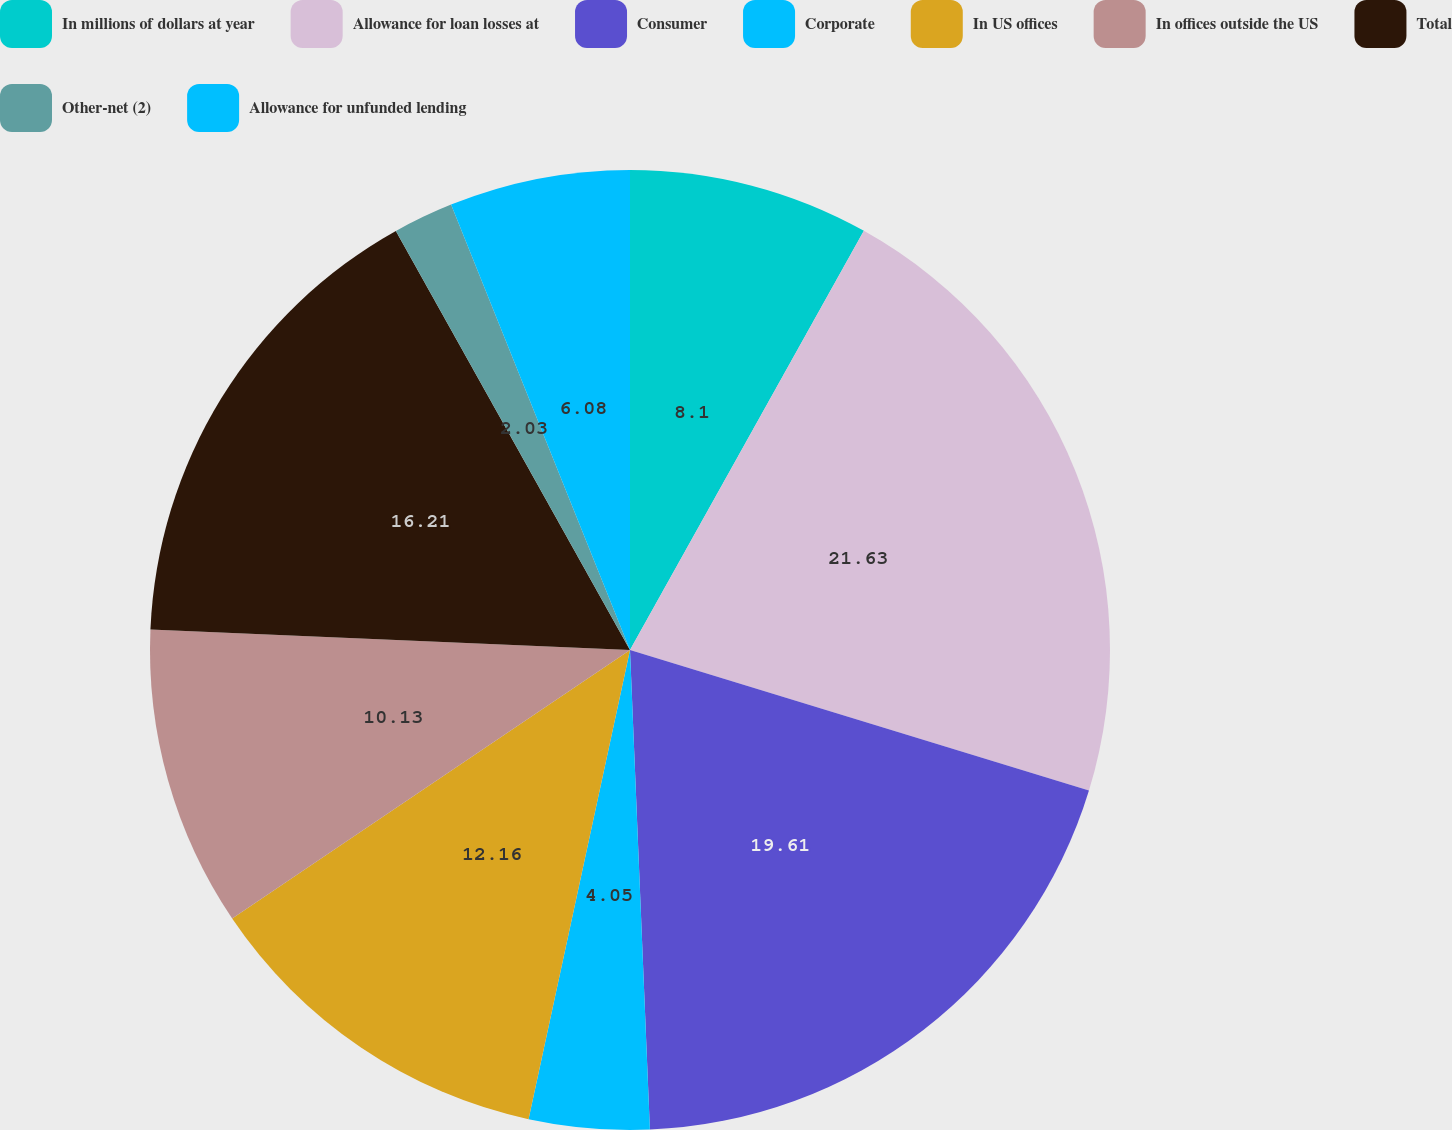Convert chart. <chart><loc_0><loc_0><loc_500><loc_500><pie_chart><fcel>In millions of dollars at year<fcel>Allowance for loan losses at<fcel>Consumer<fcel>Corporate<fcel>In US offices<fcel>In offices outside the US<fcel>Total<fcel>Other-net (2)<fcel>Allowance for unfunded lending<nl><fcel>8.1%<fcel>21.63%<fcel>19.61%<fcel>4.05%<fcel>12.16%<fcel>10.13%<fcel>16.21%<fcel>2.03%<fcel>6.08%<nl></chart> 